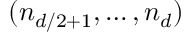<formula> <loc_0><loc_0><loc_500><loc_500>( n _ { d / 2 + 1 } , \dots , n _ { d } )</formula> 